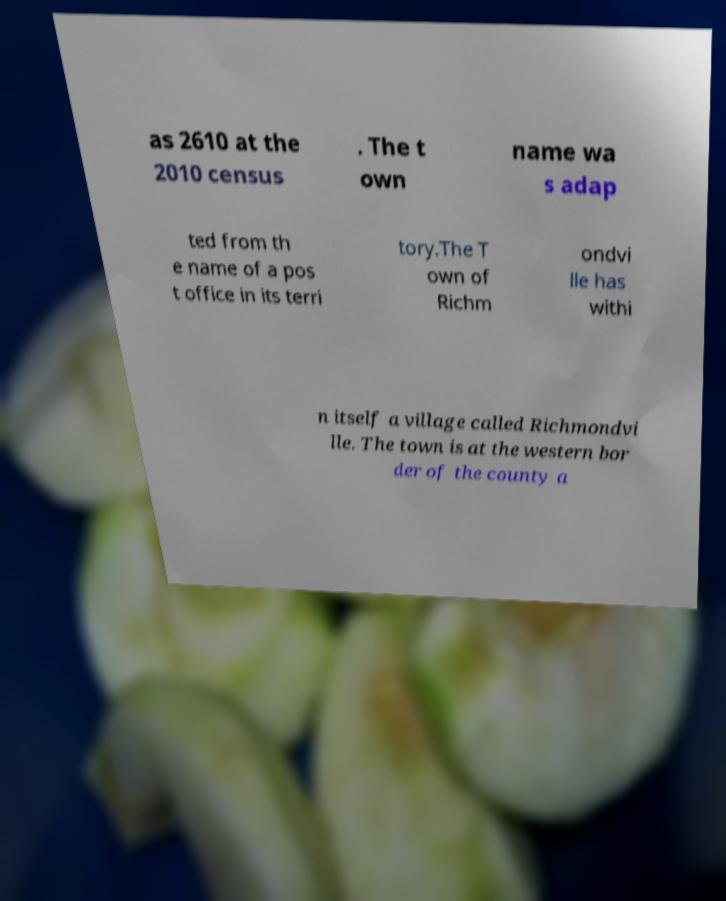Can you read and provide the text displayed in the image?This photo seems to have some interesting text. Can you extract and type it out for me? as 2610 at the 2010 census . The t own name wa s adap ted from th e name of a pos t office in its terri tory.The T own of Richm ondvi lle has withi n itself a village called Richmondvi lle. The town is at the western bor der of the county a 